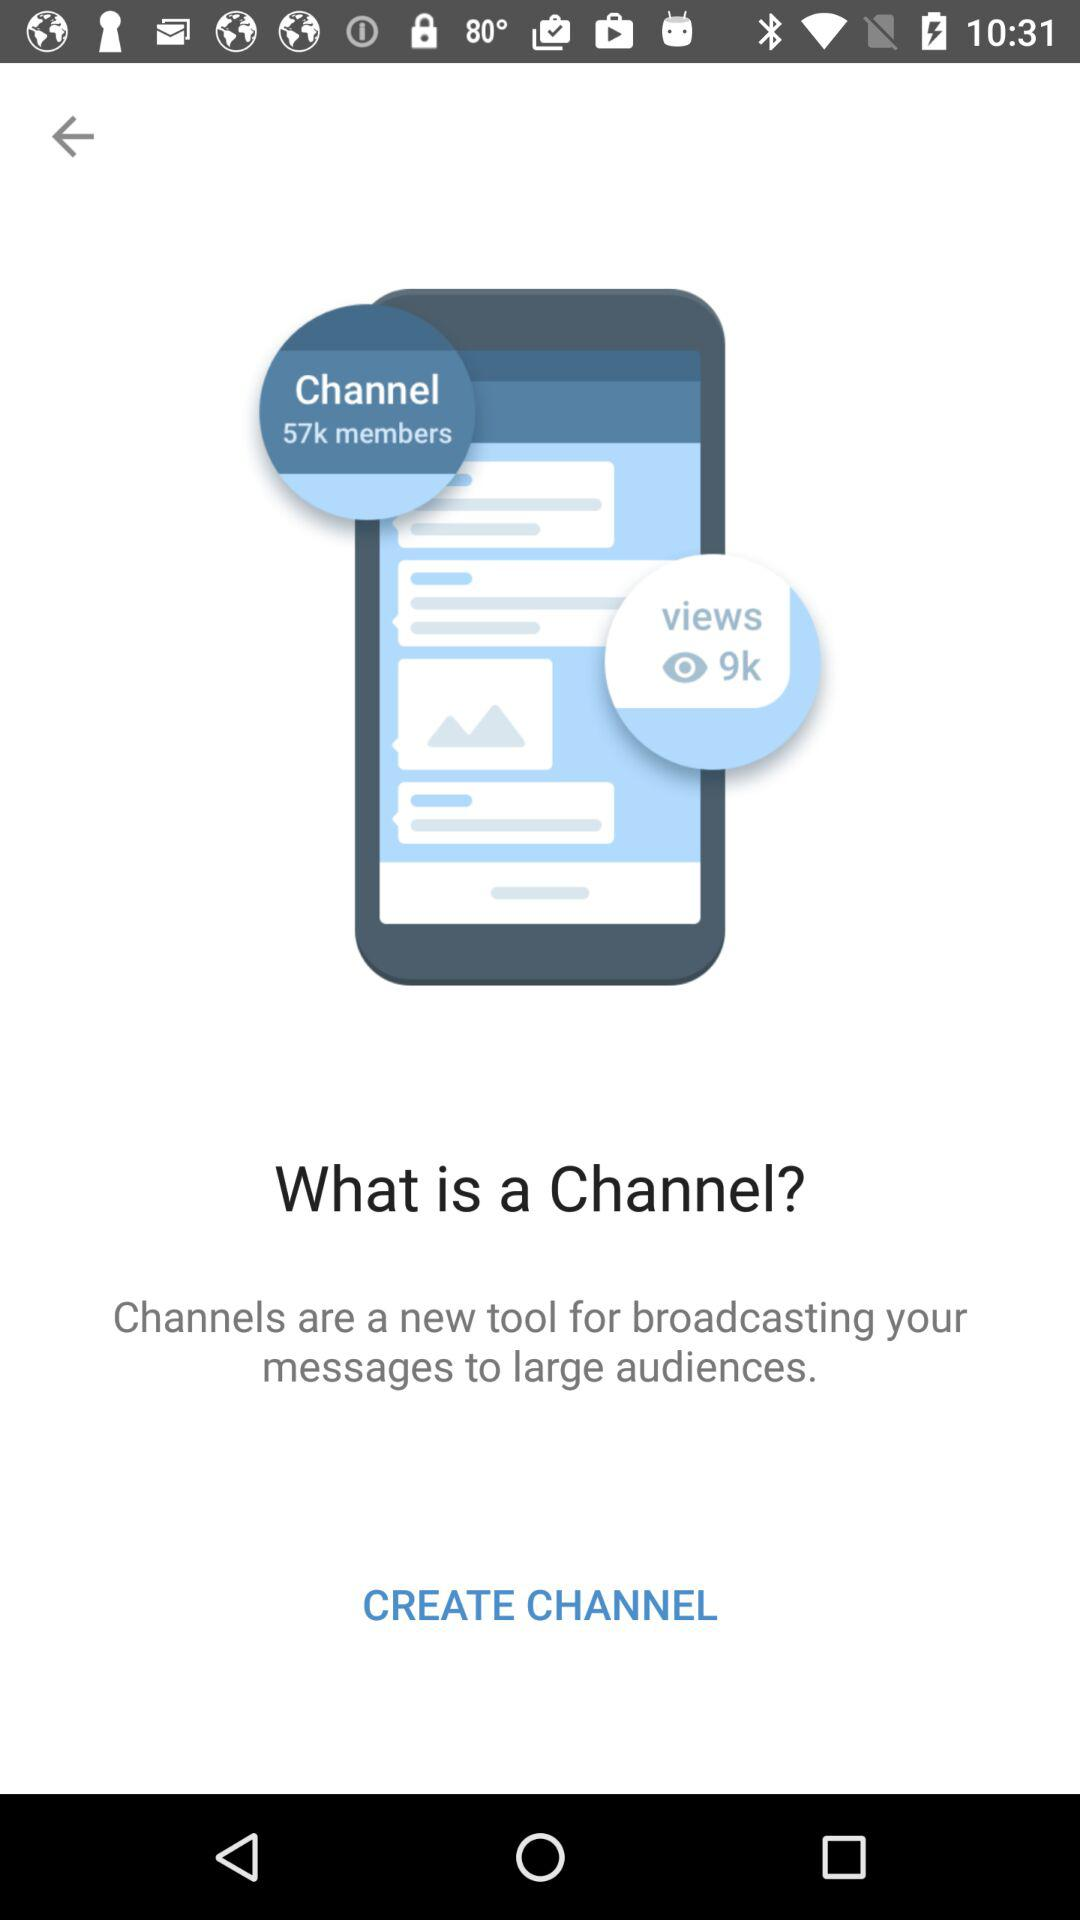How many views are there? There are 9k views. 